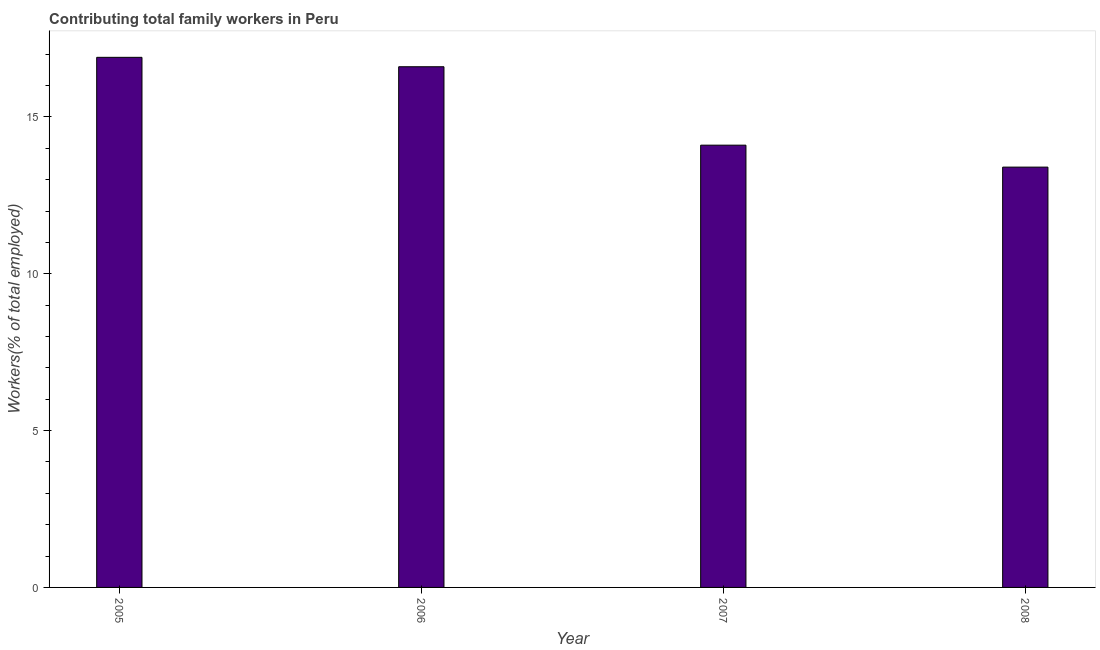Does the graph contain any zero values?
Your response must be concise. No. What is the title of the graph?
Your response must be concise. Contributing total family workers in Peru. What is the label or title of the X-axis?
Offer a very short reply. Year. What is the label or title of the Y-axis?
Keep it short and to the point. Workers(% of total employed). What is the contributing family workers in 2008?
Provide a succinct answer. 13.4. Across all years, what is the maximum contributing family workers?
Give a very brief answer. 16.9. Across all years, what is the minimum contributing family workers?
Keep it short and to the point. 13.4. In which year was the contributing family workers maximum?
Give a very brief answer. 2005. What is the sum of the contributing family workers?
Your answer should be compact. 61. What is the average contributing family workers per year?
Make the answer very short. 15.25. What is the median contributing family workers?
Offer a very short reply. 15.35. In how many years, is the contributing family workers greater than 13 %?
Offer a very short reply. 4. What is the ratio of the contributing family workers in 2007 to that in 2008?
Give a very brief answer. 1.05. Is the difference between the contributing family workers in 2007 and 2008 greater than the difference between any two years?
Offer a very short reply. No. Is the sum of the contributing family workers in 2007 and 2008 greater than the maximum contributing family workers across all years?
Make the answer very short. Yes. What is the difference between the highest and the lowest contributing family workers?
Give a very brief answer. 3.5. How many bars are there?
Your response must be concise. 4. What is the difference between two consecutive major ticks on the Y-axis?
Offer a terse response. 5. Are the values on the major ticks of Y-axis written in scientific E-notation?
Ensure brevity in your answer.  No. What is the Workers(% of total employed) in 2005?
Keep it short and to the point. 16.9. What is the Workers(% of total employed) of 2006?
Provide a short and direct response. 16.6. What is the Workers(% of total employed) in 2007?
Your response must be concise. 14.1. What is the Workers(% of total employed) of 2008?
Provide a short and direct response. 13.4. What is the difference between the Workers(% of total employed) in 2006 and 2007?
Your response must be concise. 2.5. What is the difference between the Workers(% of total employed) in 2006 and 2008?
Keep it short and to the point. 3.2. What is the difference between the Workers(% of total employed) in 2007 and 2008?
Give a very brief answer. 0.7. What is the ratio of the Workers(% of total employed) in 2005 to that in 2006?
Make the answer very short. 1.02. What is the ratio of the Workers(% of total employed) in 2005 to that in 2007?
Ensure brevity in your answer.  1.2. What is the ratio of the Workers(% of total employed) in 2005 to that in 2008?
Keep it short and to the point. 1.26. What is the ratio of the Workers(% of total employed) in 2006 to that in 2007?
Keep it short and to the point. 1.18. What is the ratio of the Workers(% of total employed) in 2006 to that in 2008?
Give a very brief answer. 1.24. What is the ratio of the Workers(% of total employed) in 2007 to that in 2008?
Keep it short and to the point. 1.05. 